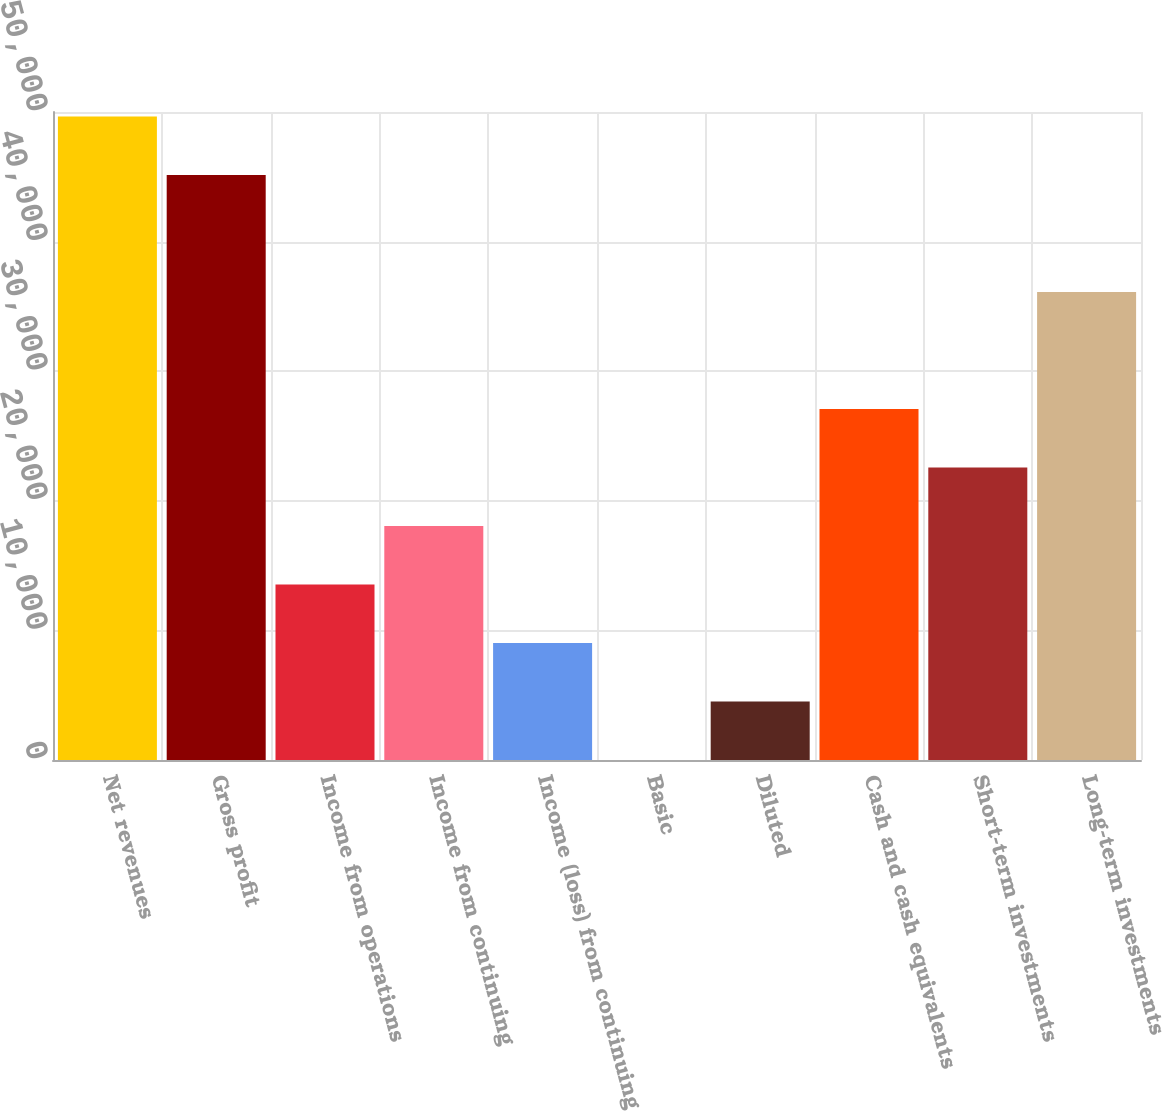Convert chart. <chart><loc_0><loc_0><loc_500><loc_500><bar_chart><fcel>Net revenues<fcel>Gross profit<fcel>Income from operations<fcel>Income from continuing<fcel>Income (loss) from continuing<fcel>Basic<fcel>Diluted<fcel>Cash and cash equivalents<fcel>Short-term investments<fcel>Long-term investments<nl><fcel>49645.1<fcel>45132<fcel>13540.1<fcel>18053.2<fcel>9026.95<fcel>0.69<fcel>4513.82<fcel>27079.5<fcel>22566.3<fcel>36105.7<nl></chart> 